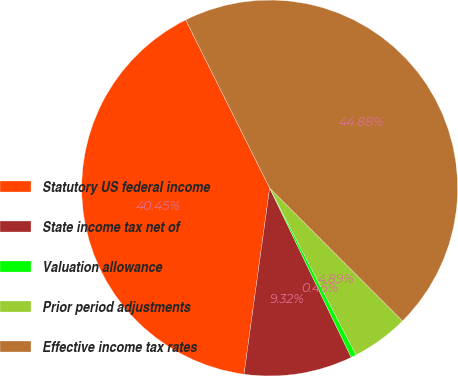<chart> <loc_0><loc_0><loc_500><loc_500><pie_chart><fcel>Statutory US federal income<fcel>State income tax net of<fcel>Valuation allowance<fcel>Prior period adjustments<fcel>Effective income tax rates<nl><fcel>40.45%<fcel>9.32%<fcel>0.46%<fcel>4.89%<fcel>44.88%<nl></chart> 